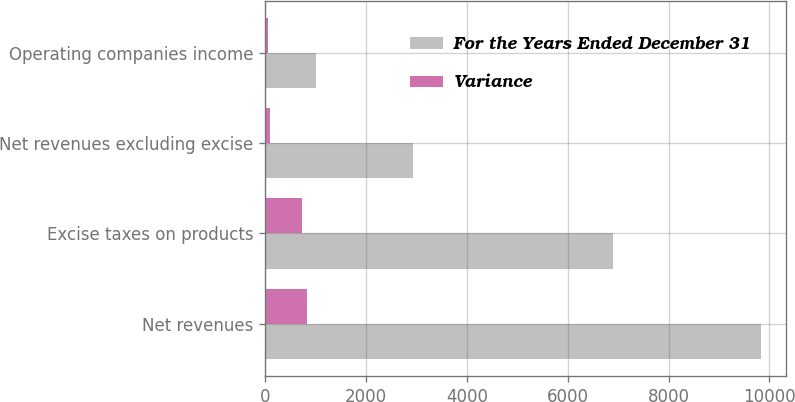Convert chart to OTSL. <chart><loc_0><loc_0><loc_500><loc_500><stacked_bar_chart><ecel><fcel>Net revenues<fcel>Excise taxes on products<fcel>Net revenues excluding excise<fcel>Operating companies income<nl><fcel>For the Years Ended December 31<fcel>9838<fcel>6897<fcel>2941<fcel>1002<nl><fcel>Variance<fcel>831<fcel>732<fcel>99<fcel>64<nl></chart> 